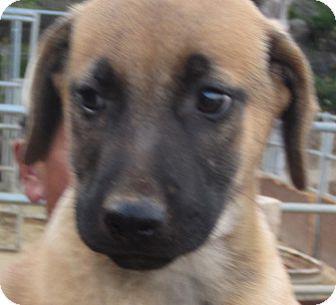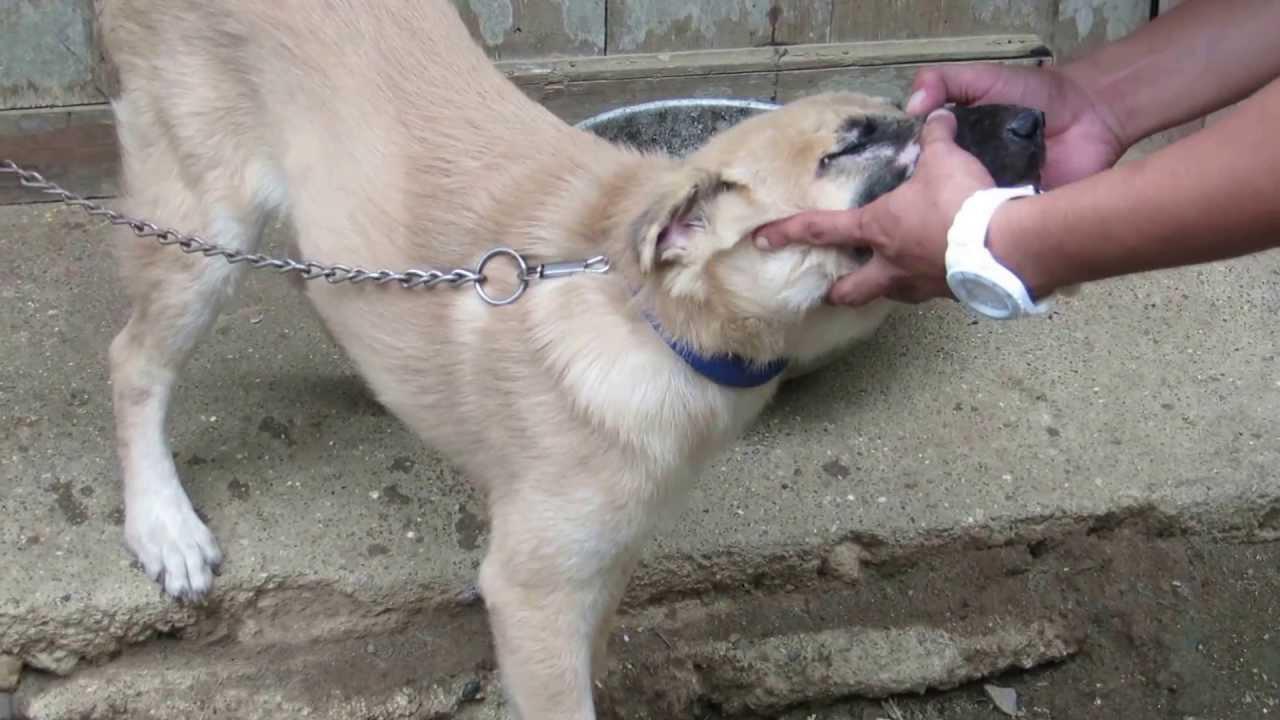The first image is the image on the left, the second image is the image on the right. Examine the images to the left and right. Is the description "The picture focuses on the front of the of young tan puppies with black noses." accurate? Answer yes or no. Yes. The first image is the image on the left, the second image is the image on the right. Given the left and right images, does the statement "black german shepards are oposite each other" hold true? Answer yes or no. No. The first image is the image on the left, the second image is the image on the right. Considering the images on both sides, is "An image shows a black dog with erect, pointed ears." valid? Answer yes or no. No. 